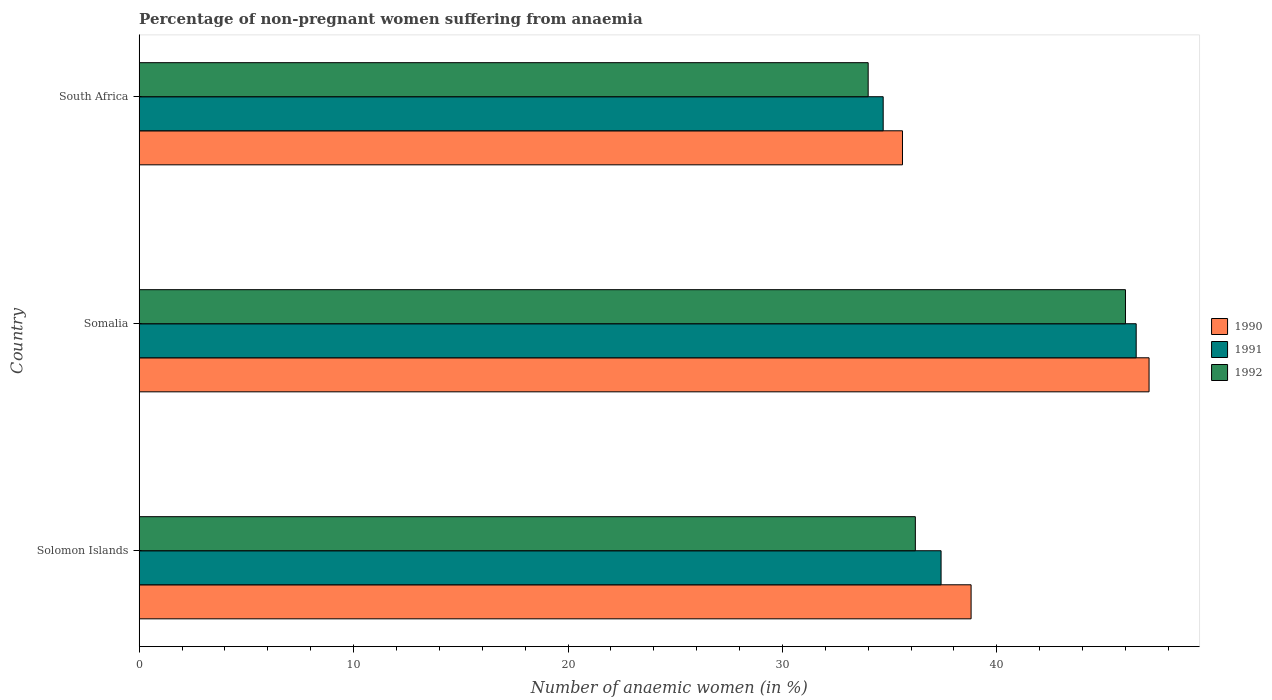How many groups of bars are there?
Provide a short and direct response. 3. Are the number of bars per tick equal to the number of legend labels?
Your answer should be compact. Yes. Are the number of bars on each tick of the Y-axis equal?
Give a very brief answer. Yes. What is the label of the 3rd group of bars from the top?
Provide a succinct answer. Solomon Islands. In how many cases, is the number of bars for a given country not equal to the number of legend labels?
Your answer should be compact. 0. What is the percentage of non-pregnant women suffering from anaemia in 1990 in Somalia?
Provide a short and direct response. 47.1. Across all countries, what is the maximum percentage of non-pregnant women suffering from anaemia in 1992?
Ensure brevity in your answer.  46. Across all countries, what is the minimum percentage of non-pregnant women suffering from anaemia in 1991?
Your answer should be very brief. 34.7. In which country was the percentage of non-pregnant women suffering from anaemia in 1991 maximum?
Your response must be concise. Somalia. In which country was the percentage of non-pregnant women suffering from anaemia in 1990 minimum?
Provide a succinct answer. South Africa. What is the total percentage of non-pregnant women suffering from anaemia in 1992 in the graph?
Ensure brevity in your answer.  116.2. What is the difference between the percentage of non-pregnant women suffering from anaemia in 1990 in Solomon Islands and that in South Africa?
Provide a short and direct response. 3.2. What is the difference between the percentage of non-pregnant women suffering from anaemia in 1991 in Solomon Islands and the percentage of non-pregnant women suffering from anaemia in 1990 in South Africa?
Provide a short and direct response. 1.8. What is the average percentage of non-pregnant women suffering from anaemia in 1992 per country?
Your answer should be very brief. 38.73. What is the difference between the percentage of non-pregnant women suffering from anaemia in 1992 and percentage of non-pregnant women suffering from anaemia in 1991 in Somalia?
Offer a very short reply. -0.5. In how many countries, is the percentage of non-pregnant women suffering from anaemia in 1990 greater than 38 %?
Provide a short and direct response. 2. What is the ratio of the percentage of non-pregnant women suffering from anaemia in 1992 in Solomon Islands to that in South Africa?
Offer a terse response. 1.06. Is the percentage of non-pregnant women suffering from anaemia in 1990 in Solomon Islands less than that in Somalia?
Offer a very short reply. Yes. Is the difference between the percentage of non-pregnant women suffering from anaemia in 1992 in Somalia and South Africa greater than the difference between the percentage of non-pregnant women suffering from anaemia in 1991 in Somalia and South Africa?
Your response must be concise. Yes. What is the difference between the highest and the second highest percentage of non-pregnant women suffering from anaemia in 1992?
Give a very brief answer. 9.8. What is the difference between the highest and the lowest percentage of non-pregnant women suffering from anaemia in 1992?
Ensure brevity in your answer.  12. What does the 2nd bar from the bottom in Solomon Islands represents?
Your answer should be very brief. 1991. Is it the case that in every country, the sum of the percentage of non-pregnant women suffering from anaemia in 1990 and percentage of non-pregnant women suffering from anaemia in 1992 is greater than the percentage of non-pregnant women suffering from anaemia in 1991?
Give a very brief answer. Yes. How many bars are there?
Provide a short and direct response. 9. Are all the bars in the graph horizontal?
Keep it short and to the point. Yes. What is the difference between two consecutive major ticks on the X-axis?
Keep it short and to the point. 10. Are the values on the major ticks of X-axis written in scientific E-notation?
Provide a succinct answer. No. Does the graph contain any zero values?
Provide a short and direct response. No. Does the graph contain grids?
Offer a very short reply. No. Where does the legend appear in the graph?
Provide a succinct answer. Center right. What is the title of the graph?
Your response must be concise. Percentage of non-pregnant women suffering from anaemia. Does "2005" appear as one of the legend labels in the graph?
Give a very brief answer. No. What is the label or title of the X-axis?
Offer a very short reply. Number of anaemic women (in %). What is the Number of anaemic women (in %) in 1990 in Solomon Islands?
Offer a terse response. 38.8. What is the Number of anaemic women (in %) of 1991 in Solomon Islands?
Keep it short and to the point. 37.4. What is the Number of anaemic women (in %) of 1992 in Solomon Islands?
Offer a very short reply. 36.2. What is the Number of anaemic women (in %) of 1990 in Somalia?
Give a very brief answer. 47.1. What is the Number of anaemic women (in %) of 1991 in Somalia?
Make the answer very short. 46.5. What is the Number of anaemic women (in %) in 1990 in South Africa?
Your response must be concise. 35.6. What is the Number of anaemic women (in %) of 1991 in South Africa?
Provide a succinct answer. 34.7. What is the Number of anaemic women (in %) in 1992 in South Africa?
Provide a short and direct response. 34. Across all countries, what is the maximum Number of anaemic women (in %) in 1990?
Provide a short and direct response. 47.1. Across all countries, what is the maximum Number of anaemic women (in %) in 1991?
Ensure brevity in your answer.  46.5. Across all countries, what is the maximum Number of anaemic women (in %) in 1992?
Your answer should be very brief. 46. Across all countries, what is the minimum Number of anaemic women (in %) in 1990?
Keep it short and to the point. 35.6. Across all countries, what is the minimum Number of anaemic women (in %) of 1991?
Provide a succinct answer. 34.7. Across all countries, what is the minimum Number of anaemic women (in %) in 1992?
Keep it short and to the point. 34. What is the total Number of anaemic women (in %) in 1990 in the graph?
Provide a succinct answer. 121.5. What is the total Number of anaemic women (in %) in 1991 in the graph?
Your answer should be very brief. 118.6. What is the total Number of anaemic women (in %) of 1992 in the graph?
Ensure brevity in your answer.  116.2. What is the difference between the Number of anaemic women (in %) in 1990 in Solomon Islands and that in Somalia?
Give a very brief answer. -8.3. What is the difference between the Number of anaemic women (in %) of 1991 in Solomon Islands and that in Somalia?
Offer a very short reply. -9.1. What is the difference between the Number of anaemic women (in %) of 1992 in Solomon Islands and that in Somalia?
Offer a terse response. -9.8. What is the difference between the Number of anaemic women (in %) of 1992 in Solomon Islands and that in South Africa?
Provide a succinct answer. 2.2. What is the difference between the Number of anaemic women (in %) of 1990 in Somalia and that in South Africa?
Provide a succinct answer. 11.5. What is the difference between the Number of anaemic women (in %) of 1991 in Somalia and that in South Africa?
Your answer should be very brief. 11.8. What is the difference between the Number of anaemic women (in %) in 1990 in Solomon Islands and the Number of anaemic women (in %) in 1992 in Somalia?
Give a very brief answer. -7.2. What is the difference between the Number of anaemic women (in %) in 1991 in Solomon Islands and the Number of anaemic women (in %) in 1992 in Somalia?
Offer a terse response. -8.6. What is the difference between the Number of anaemic women (in %) in 1990 in Solomon Islands and the Number of anaemic women (in %) in 1991 in South Africa?
Your answer should be very brief. 4.1. What is the difference between the Number of anaemic women (in %) of 1991 in Solomon Islands and the Number of anaemic women (in %) of 1992 in South Africa?
Your answer should be compact. 3.4. What is the difference between the Number of anaemic women (in %) of 1990 in Somalia and the Number of anaemic women (in %) of 1991 in South Africa?
Ensure brevity in your answer.  12.4. What is the difference between the Number of anaemic women (in %) in 1990 in Somalia and the Number of anaemic women (in %) in 1992 in South Africa?
Your answer should be compact. 13.1. What is the difference between the Number of anaemic women (in %) in 1991 in Somalia and the Number of anaemic women (in %) in 1992 in South Africa?
Ensure brevity in your answer.  12.5. What is the average Number of anaemic women (in %) in 1990 per country?
Offer a very short reply. 40.5. What is the average Number of anaemic women (in %) of 1991 per country?
Provide a short and direct response. 39.53. What is the average Number of anaemic women (in %) in 1992 per country?
Offer a very short reply. 38.73. What is the difference between the Number of anaemic women (in %) in 1990 and Number of anaemic women (in %) in 1991 in Solomon Islands?
Provide a succinct answer. 1.4. What is the difference between the Number of anaemic women (in %) in 1991 and Number of anaemic women (in %) in 1992 in Solomon Islands?
Your response must be concise. 1.2. What is the difference between the Number of anaemic women (in %) of 1990 and Number of anaemic women (in %) of 1991 in Somalia?
Provide a succinct answer. 0.6. What is the difference between the Number of anaemic women (in %) in 1991 and Number of anaemic women (in %) in 1992 in Somalia?
Your response must be concise. 0.5. What is the difference between the Number of anaemic women (in %) in 1990 and Number of anaemic women (in %) in 1992 in South Africa?
Provide a short and direct response. 1.6. What is the difference between the Number of anaemic women (in %) of 1991 and Number of anaemic women (in %) of 1992 in South Africa?
Offer a very short reply. 0.7. What is the ratio of the Number of anaemic women (in %) in 1990 in Solomon Islands to that in Somalia?
Your answer should be compact. 0.82. What is the ratio of the Number of anaemic women (in %) in 1991 in Solomon Islands to that in Somalia?
Offer a very short reply. 0.8. What is the ratio of the Number of anaemic women (in %) in 1992 in Solomon Islands to that in Somalia?
Offer a terse response. 0.79. What is the ratio of the Number of anaemic women (in %) of 1990 in Solomon Islands to that in South Africa?
Your answer should be compact. 1.09. What is the ratio of the Number of anaemic women (in %) in 1991 in Solomon Islands to that in South Africa?
Ensure brevity in your answer.  1.08. What is the ratio of the Number of anaemic women (in %) in 1992 in Solomon Islands to that in South Africa?
Make the answer very short. 1.06. What is the ratio of the Number of anaemic women (in %) in 1990 in Somalia to that in South Africa?
Offer a terse response. 1.32. What is the ratio of the Number of anaemic women (in %) of 1991 in Somalia to that in South Africa?
Give a very brief answer. 1.34. What is the ratio of the Number of anaemic women (in %) of 1992 in Somalia to that in South Africa?
Your answer should be very brief. 1.35. What is the difference between the highest and the second highest Number of anaemic women (in %) of 1991?
Your answer should be compact. 9.1. What is the difference between the highest and the second highest Number of anaemic women (in %) of 1992?
Ensure brevity in your answer.  9.8. What is the difference between the highest and the lowest Number of anaemic women (in %) in 1990?
Your response must be concise. 11.5. What is the difference between the highest and the lowest Number of anaemic women (in %) of 1992?
Your answer should be compact. 12. 